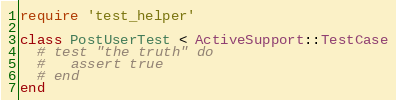<code> <loc_0><loc_0><loc_500><loc_500><_Ruby_>require 'test_helper'

class PostUserTest < ActiveSupport::TestCase
  # test "the truth" do
  #   assert true
  # end
end
</code> 